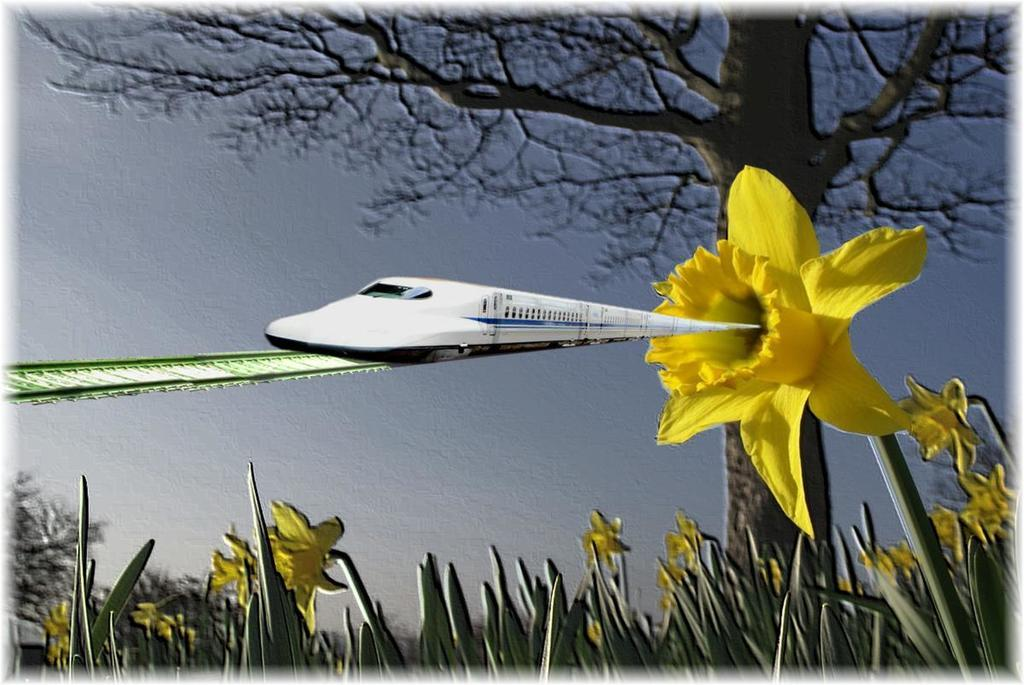How was the image manipulated or altered? The image is edited. What type of flowers can be seen at the bottom of the image? There are yellow color flowers at the bottom of the image. What is located on the right side of the image? There is a tree on the right side of the image. What is happening in the middle of the image? A train is moving in the middle of the image. On what surface is the train traveling? The train is on a railway track. What part of the natural environment is visible in the image? The sky is visible in the image. Where is the lunchroom located in the image? There is no lunchroom present in the image. What type of question is being asked in the image? There is no question being asked in the image. 